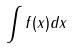<formula> <loc_0><loc_0><loc_500><loc_500>\int f ( x ) d x</formula> 